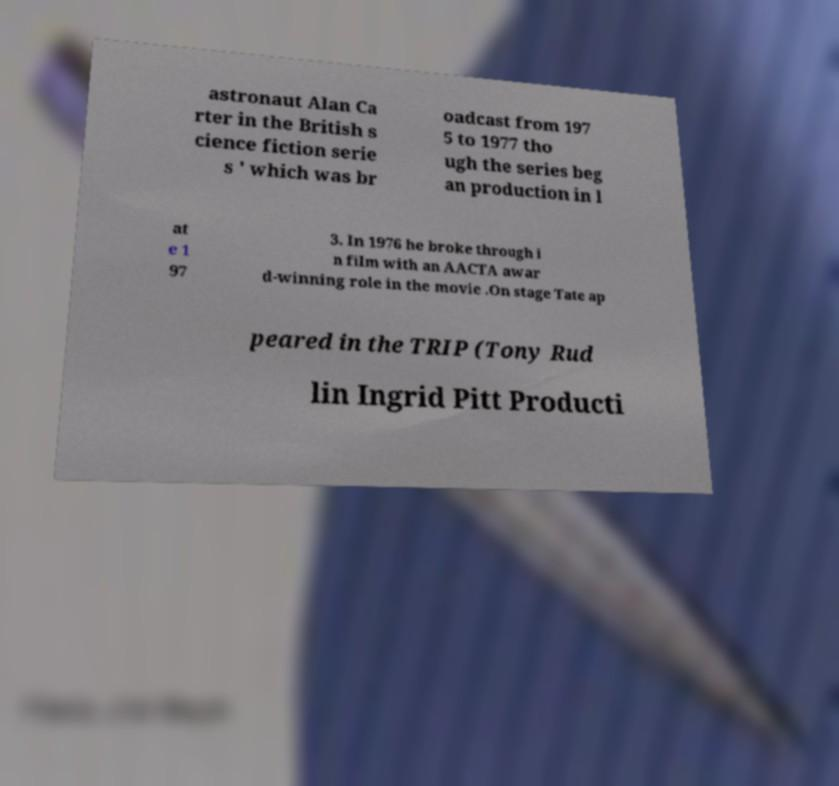For documentation purposes, I need the text within this image transcribed. Could you provide that? astronaut Alan Ca rter in the British s cience fiction serie s ' which was br oadcast from 197 5 to 1977 tho ugh the series beg an production in l at e 1 97 3. In 1976 he broke through i n film with an AACTA awar d-winning role in the movie .On stage Tate ap peared in the TRIP (Tony Rud lin Ingrid Pitt Producti 